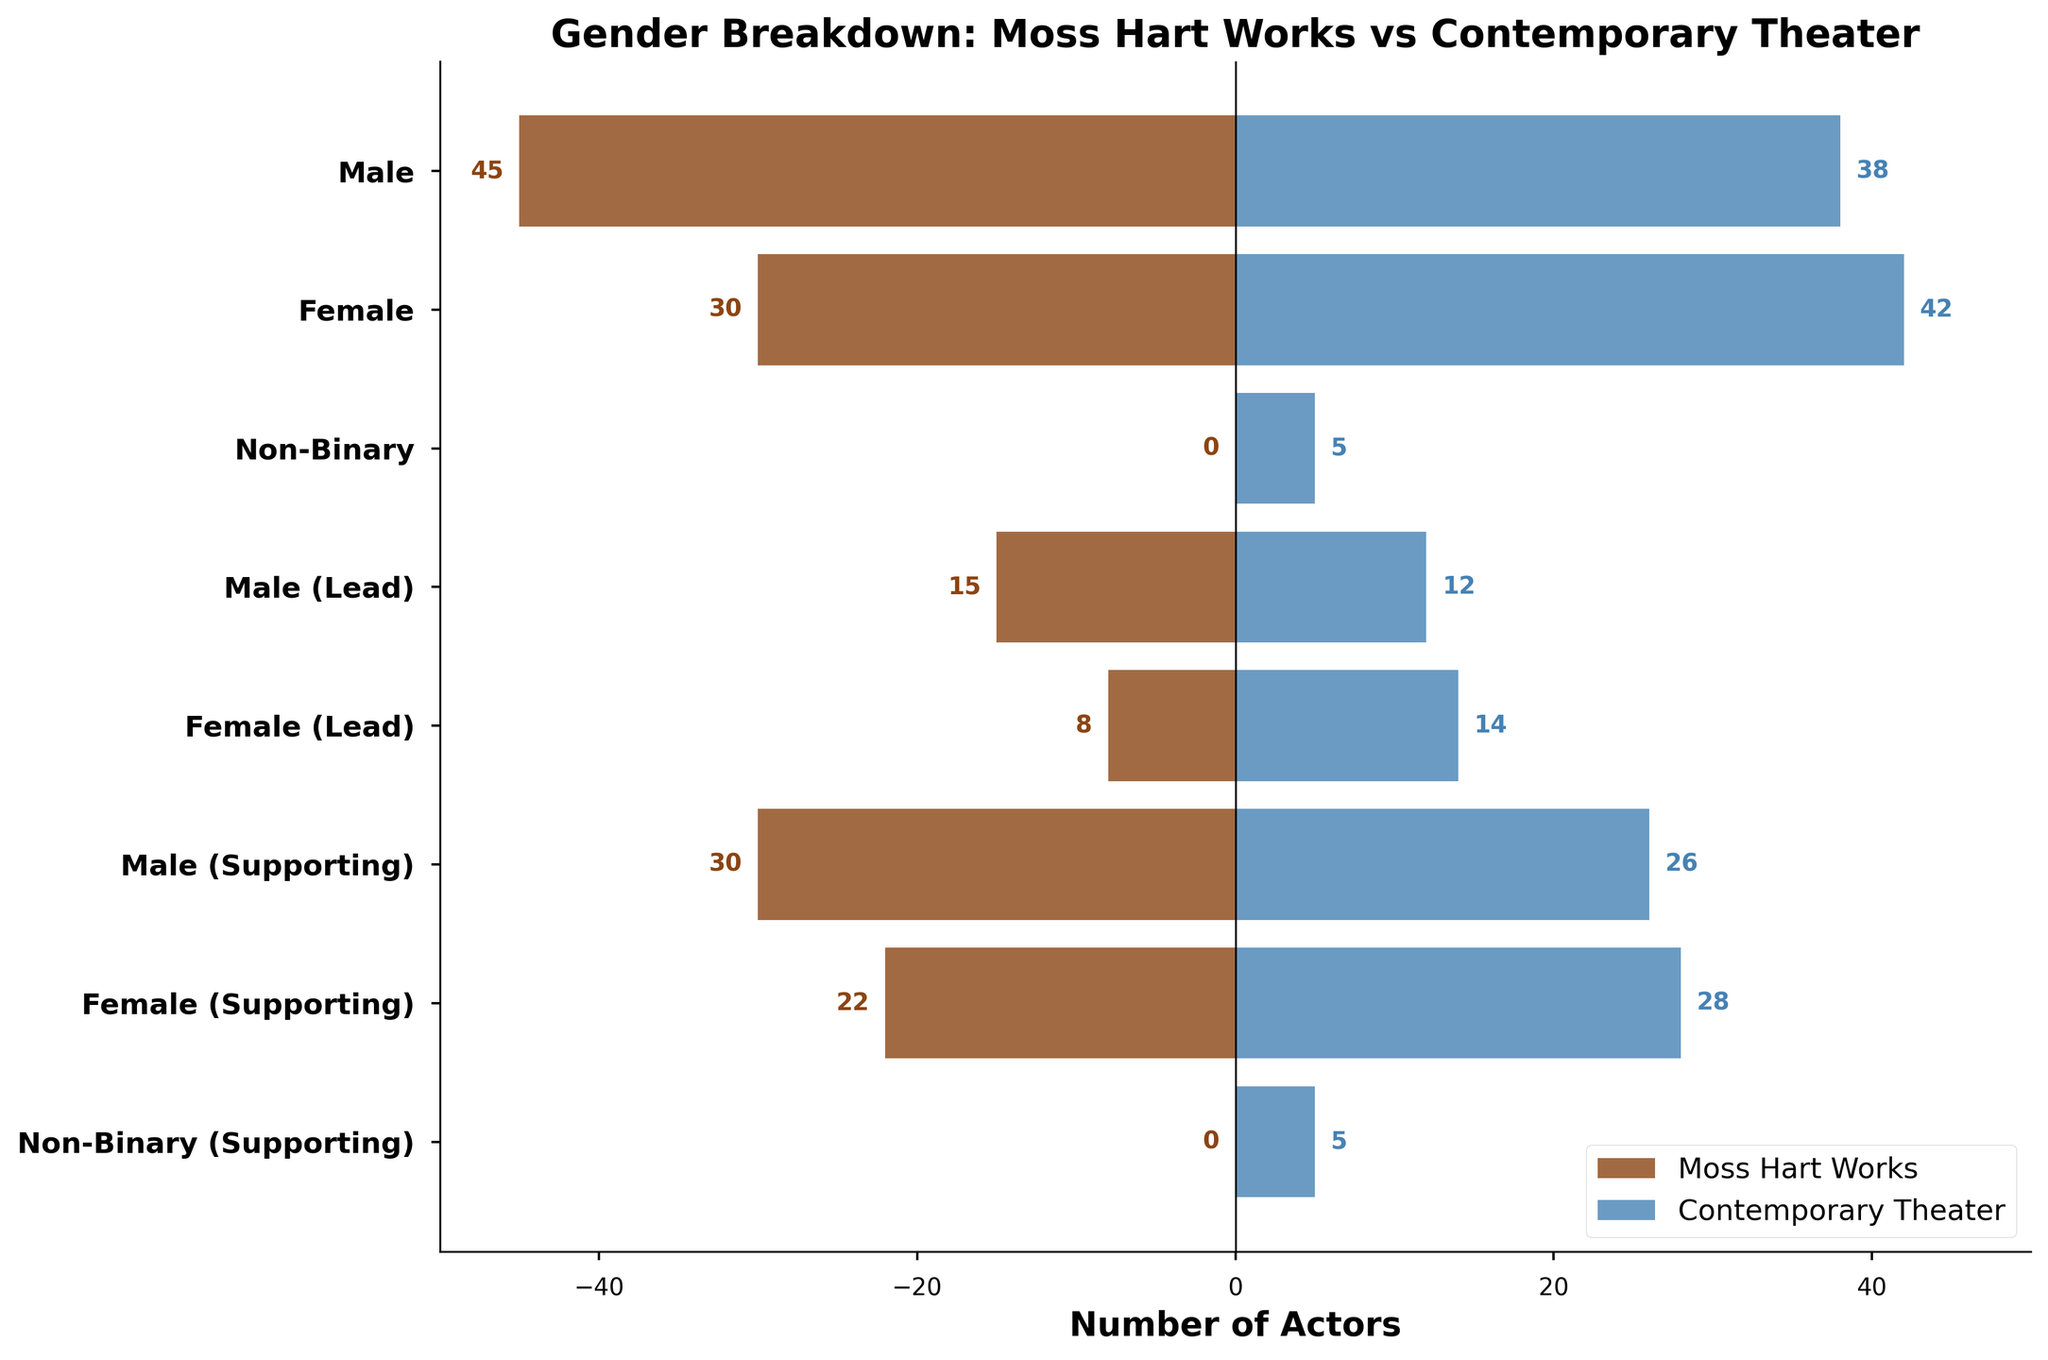What's the title of the plot? The title is typically displayed at the top of the plot, summarizing the main subject of the figure. In this case, it's written above the bars.
Answer: Gender Breakdown: Moss Hart Works vs Contemporary Theater What colors represent Moss Hart's works and contemporary theater? The colors corresponding to Moss Hart's works and contemporary theater are shown in the legend located at the bottom-right of the plot.
Answer: Brown and blue How many male actors are in Moss Hart's works? Look at the section labeled 'Male' on the left side of the population pyramid; the bar representing Moss Hart's works shows the value.
Answer: 45 How many non-binary actors are in contemporary theater casts? Look to the blue bar under the 'Non-Binary' category; the number of actors is shown as a label next to the bar.
Answer: 5 How does the number of female lead roles in Moss Hart's works compare to contemporary theater? Identify the bars for 'Female (Lead)' and compare their lengths, as well as the numbers labeled on these bars.
Answer: Moss Hart's works have fewer female lead roles (8 vs 14) What's the total number of supporting roles in contemporary theater? Sum the numbers of 'Male (Supporting)', 'Female (Supporting)', and 'Non-Binary (Supporting)' roles for contemporary theater shown on the right side.
Answer: 59 Are there any non-binary actors in Moss Hart's works? There are no brown bars for non-binary categories in both normal and supporting roles, confirming zero non-binary actors.
Answer: No Which category has the smallest disparity between Moss Hart's works and contemporary theater? Compare the lengths and values for each category; the category with the least noticeable difference in bar lengths and values has the smallest disparity.
Answer: Female Roles (30 vs 42) How many total actors are there in Moss Hart's works across all categories? Sum the values of all the categories under Moss Hart's works.
Answer: 75 Which group has more female supporting roles: Moss Hart's works or contemporary theater? Compare the bars under 'Female (Supporting)' on both sides of the plot.
Answer: Contemporary theater 